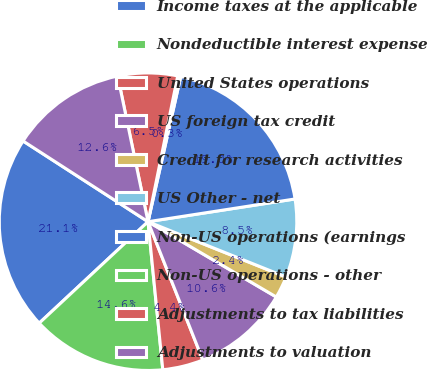Convert chart to OTSL. <chart><loc_0><loc_0><loc_500><loc_500><pie_chart><fcel>Income taxes at the applicable<fcel>Nondeductible interest expense<fcel>United States operations<fcel>US foreign tax credit<fcel>Credit for research activities<fcel>US Other - net<fcel>Non-US operations (earnings<fcel>Non-US operations - other<fcel>Adjustments to tax liabilities<fcel>Adjustments to valuation<nl><fcel>21.07%<fcel>14.64%<fcel>4.42%<fcel>10.55%<fcel>2.38%<fcel>8.51%<fcel>19.03%<fcel>0.33%<fcel>6.47%<fcel>12.6%<nl></chart> 